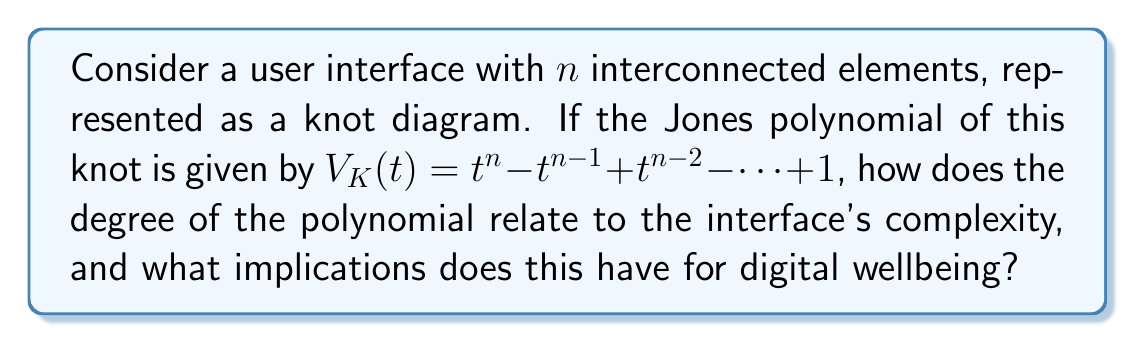Provide a solution to this math problem. To analyze this problem, let's break it down into steps:

1. The Jones polynomial is given as:
   $$V_K(t) = t^n - t^{n-1} + t^{n-2} - ... + 1$$

2. The degree of this polynomial is $n$, which corresponds to the number of interconnected elements in the user interface.

3. In knot theory, the degree of the Jones polynomial is related to the crossing number of the knot. A higher degree generally indicates a more complex knot.

4. Applying this to user interfaces:
   - A higher $n$ value suggests a more complex interface with more interconnected elements.
   - More interconnections can lead to increased cognitive load for users.

5. Digital wellbeing implications:
   - Complex interfaces (higher $n$) may require more mental effort to navigate and use.
   - This increased cognitive load could potentially lead to digital fatigue or stress.
   - Simpler interfaces (lower $n$) might promote better digital wellbeing by reducing cognitive demands.

6. The alternating signs in the polynomial ($t^n - t^{n-1} + t^{n-2} - ...$) could represent the balance between positive and negative aspects of the interface complexity.

7. The constant term (1) might represent the baseline usability of the interface, regardless of complexity.

In conclusion, the degree of the Jones polynomial ($n$) directly correlates with the interface complexity, suggesting that interfaces with higher $n$ values may pose greater challenges to users' digital wellbeing due to increased cognitive demands.
Answer: The degree $n$ of the Jones polynomial correlates with interface complexity, potentially impacting digital wellbeing through increased cognitive load. 